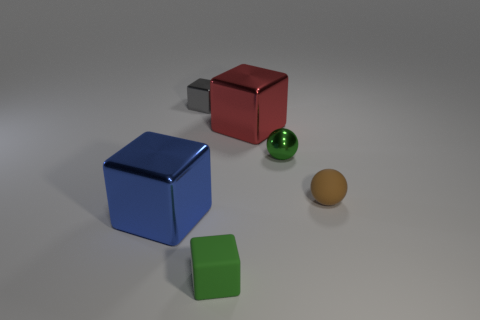Subtract all brown blocks. Subtract all cyan balls. How many blocks are left? 4 Add 3 small red spheres. How many objects exist? 9 Subtract all spheres. How many objects are left? 4 Add 6 red objects. How many red objects exist? 7 Subtract 0 yellow spheres. How many objects are left? 6 Subtract all green balls. Subtract all brown objects. How many objects are left? 4 Add 4 tiny matte blocks. How many tiny matte blocks are left? 5 